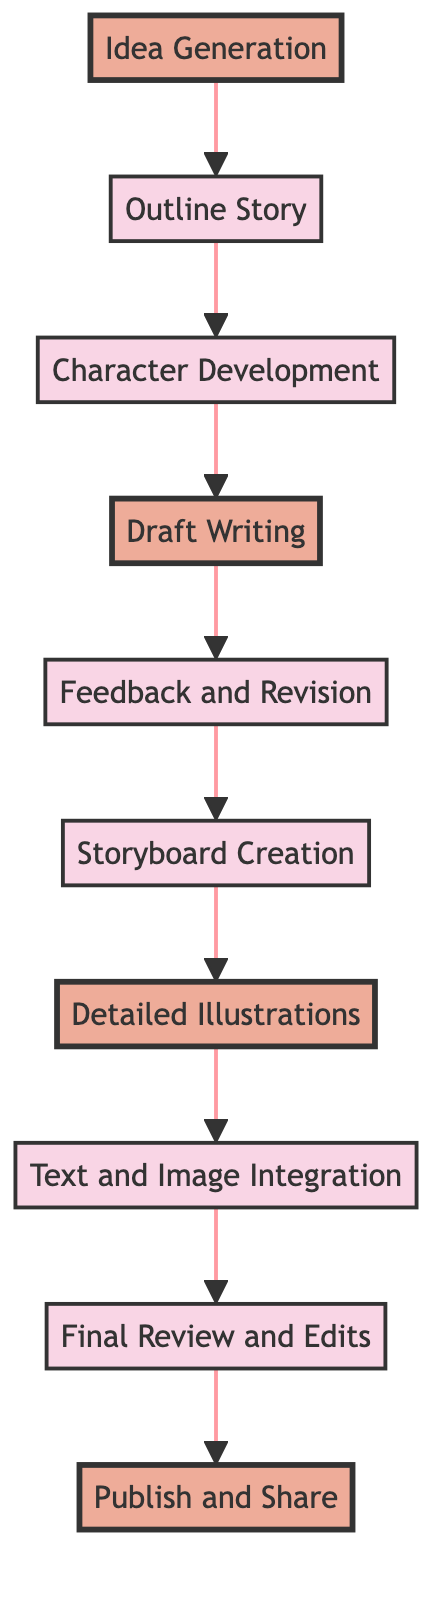What is the first step in the story development process? The diagram indicates that the first step is "Idea Generation." This can be identified by looking at the starting node of the flowchart.
Answer: Idea Generation How many total nodes are there in the flowchart? By counting each unique step/block in the flowchart, there are 10 nodes, starting from "Idea Generation" to "Publish and Share."
Answer: 10 What follows "Draft Writing" in the story development sequence? The flowchart shows that "Feedback and Revision" directly follows "Draft Writing," indicating the next step in the process.
Answer: Feedback and Revision Which step comes before "Detailed Illustrations"? The diagram clearly demonstrates that "Storyboard Creation" is the step that precedes "Detailed Illustrations." This can be traced back from the node of interest.
Answer: Storyboard Creation What are the highlighted steps in the diagram? The highlighted steps in the diagram are "Idea Generation," "Draft Writing," "Detailed Illustrations," and "Publish and Share." These steps are marked distinctly in the flowchart.
Answer: Idea Generation, Draft Writing, Detailed Illustrations, Publish and Share What is the last step in the process? The final node in the flowchart is "Publish and Share," indicating that this is the concluding step in the story development for a children's book.
Answer: Publish and Share How many steps are there between "Outline Story" and "Text and Image Integration"? By counting the steps from "Outline Story," which is the second step, to "Text and Image Integration," which is the eighth step, there are 6 steps in between.
Answer: 6 What is the relationship between "Character Development" and "Draft Writing"? The diagram illustrates that "Character Development" directly leads to "Draft Writing," establishing a sequential relationship between the two nodes.
Answer: Sequential relationship What kind of feedback can be expected in the "Feedback and Revision" step? The diagram suggests that this step entails sharing the draft with peers, mentors, or a writing group for constructive criticism and revisions.
Answer: Constructive criticism and revisions 